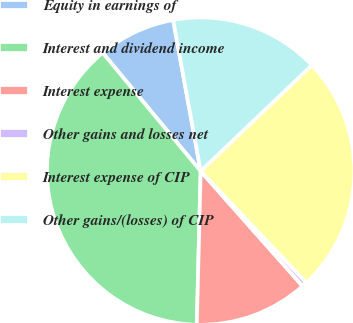Convert chart. <chart><loc_0><loc_0><loc_500><loc_500><pie_chart><fcel>Equity in earnings of<fcel>Interest and dividend income<fcel>Interest expense<fcel>Other gains and losses net<fcel>Interest expense of CIP<fcel>Other gains/(losses) of CIP<nl><fcel>8.14%<fcel>38.59%<fcel>11.95%<fcel>0.53%<fcel>25.04%<fcel>15.75%<nl></chart> 